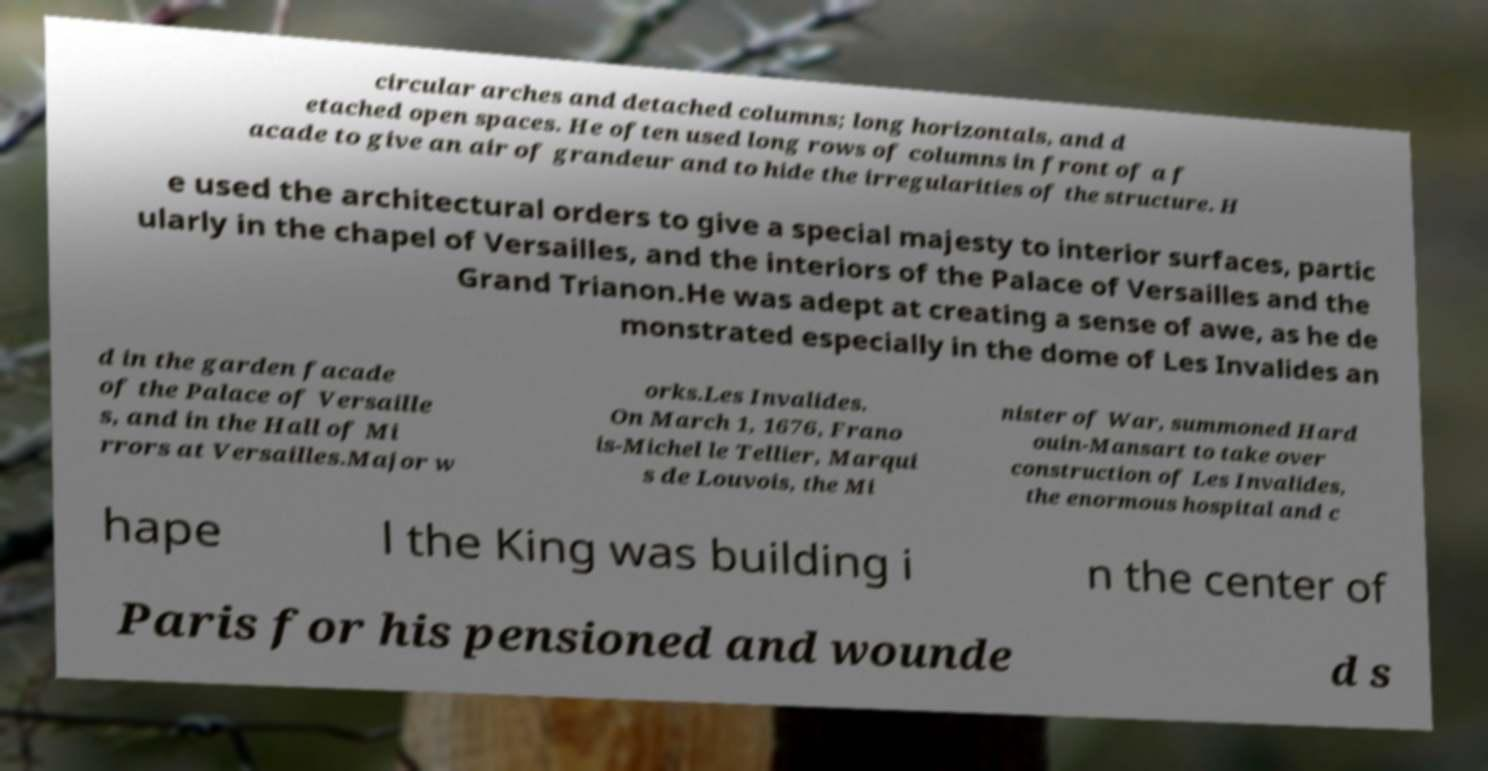Could you assist in decoding the text presented in this image and type it out clearly? circular arches and detached columns; long horizontals, and d etached open spaces. He often used long rows of columns in front of a f acade to give an air of grandeur and to hide the irregularities of the structure. H e used the architectural orders to give a special majesty to interior surfaces, partic ularly in the chapel of Versailles, and the interiors of the Palace of Versailles and the Grand Trianon.He was adept at creating a sense of awe, as he de monstrated especially in the dome of Les Invalides an d in the garden facade of the Palace of Versaille s, and in the Hall of Mi rrors at Versailles.Major w orks.Les Invalides. On March 1, 1676, Frano is-Michel le Tellier, Marqui s de Louvois, the Mi nister of War, summoned Hard ouin-Mansart to take over construction of Les Invalides, the enormous hospital and c hape l the King was building i n the center of Paris for his pensioned and wounde d s 